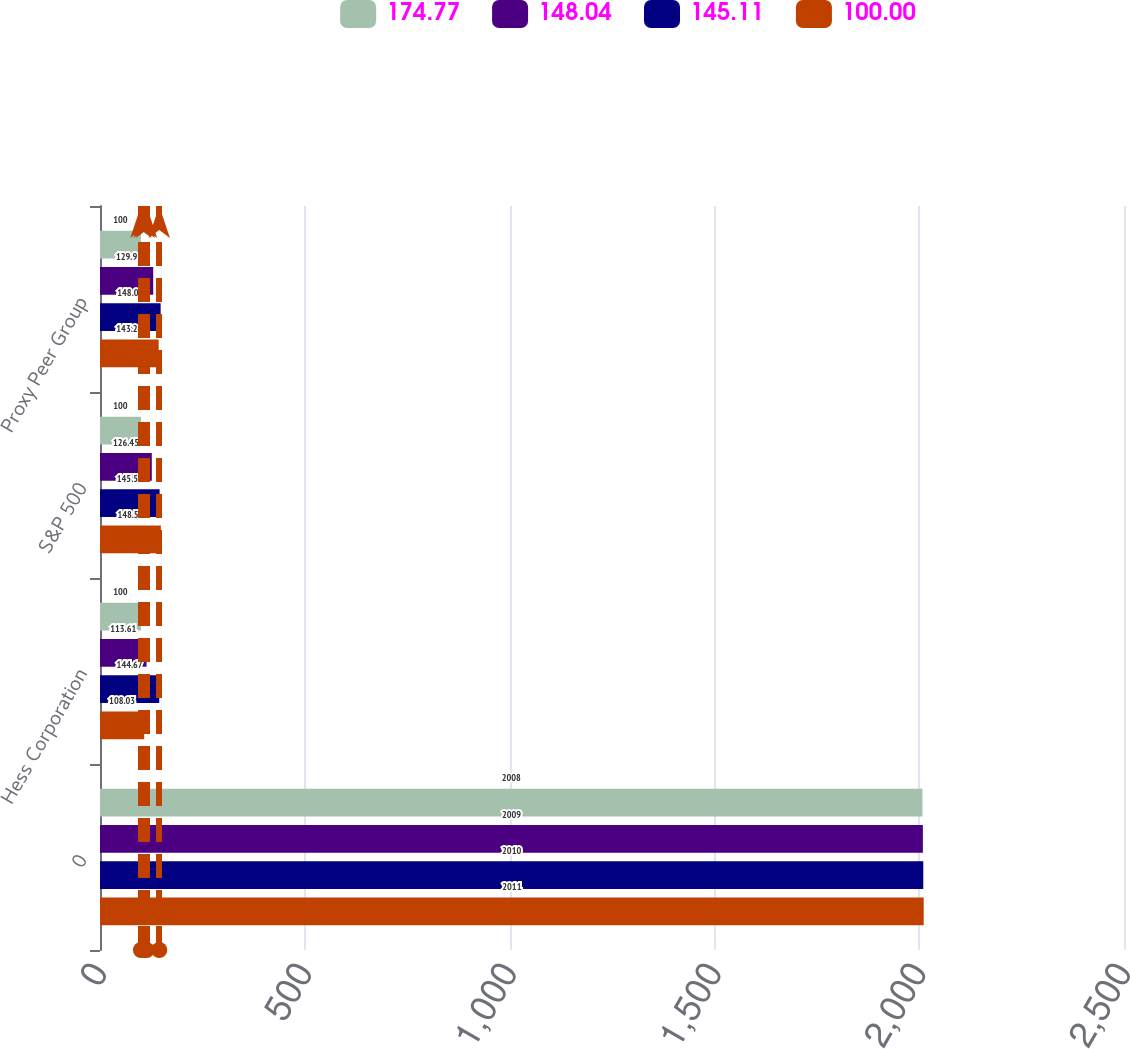Convert chart. <chart><loc_0><loc_0><loc_500><loc_500><stacked_bar_chart><ecel><fcel>0<fcel>Hess Corporation<fcel>S&P 500<fcel>Proxy Peer Group<nl><fcel>174.77<fcel>2008<fcel>100<fcel>100<fcel>100<nl><fcel>148.04<fcel>2009<fcel>113.61<fcel>126.45<fcel>129.9<nl><fcel>145.11<fcel>2010<fcel>144.67<fcel>145.52<fcel>148.04<nl><fcel>100<fcel>2011<fcel>108.03<fcel>148.55<fcel>143.24<nl></chart> 